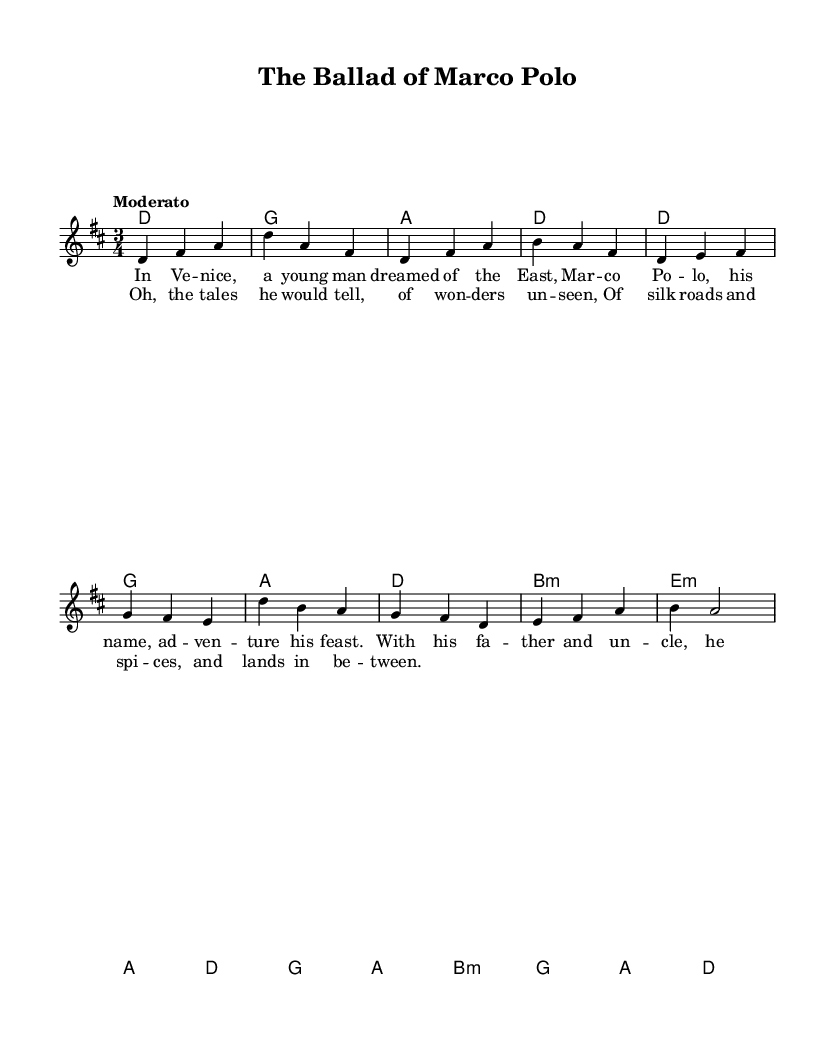What is the key signature of this music? The key signature is determined by the number of sharps or flats indicated at the beginning of the staff. In this sheet music, there is an indication of two sharps, which corresponds to D major.
Answer: D major What is the time signature of this music? The time signature can be found at the beginning of the sheet music, indicating how many beats are in each measure. Here, it shows 3/4, meaning there are three beats per measure and the quarter note gets one beat.
Answer: 3/4 What is the tempo marking of this piece? The tempo marking is usually found at the beginning of the score, indicating the speed of the piece. This sheet music has a tempo marking of "Moderato," suggesting a moderate pace.
Answer: Moderato How many verses are in the lyrics? By examining the lyrics section of the music, we can count how many distinct sections are labeled as verses. In this music, there is one verse (labeled as "verseOne") and a chorus.
Answer: One What is the first note of the melody? The first note of the melody can be seen at the beginning of the melody section, which shows a D note (represented in the staff by its position).
Answer: D Which chord is played during the chorus? To find the chord during the chorus, we look at the chord progression section that corresponds to the chorus portion of the melody. The chord sequence includes B minor when the chorus starts.
Answer: B minor What story does this folk song tell? This folk song tells the story of Marco Polo, focusing on his adventures and discoveries during his travels to the East. The narrative illustrates his journey and the wonders he encountered.
Answer: Marco Polo's adventures 